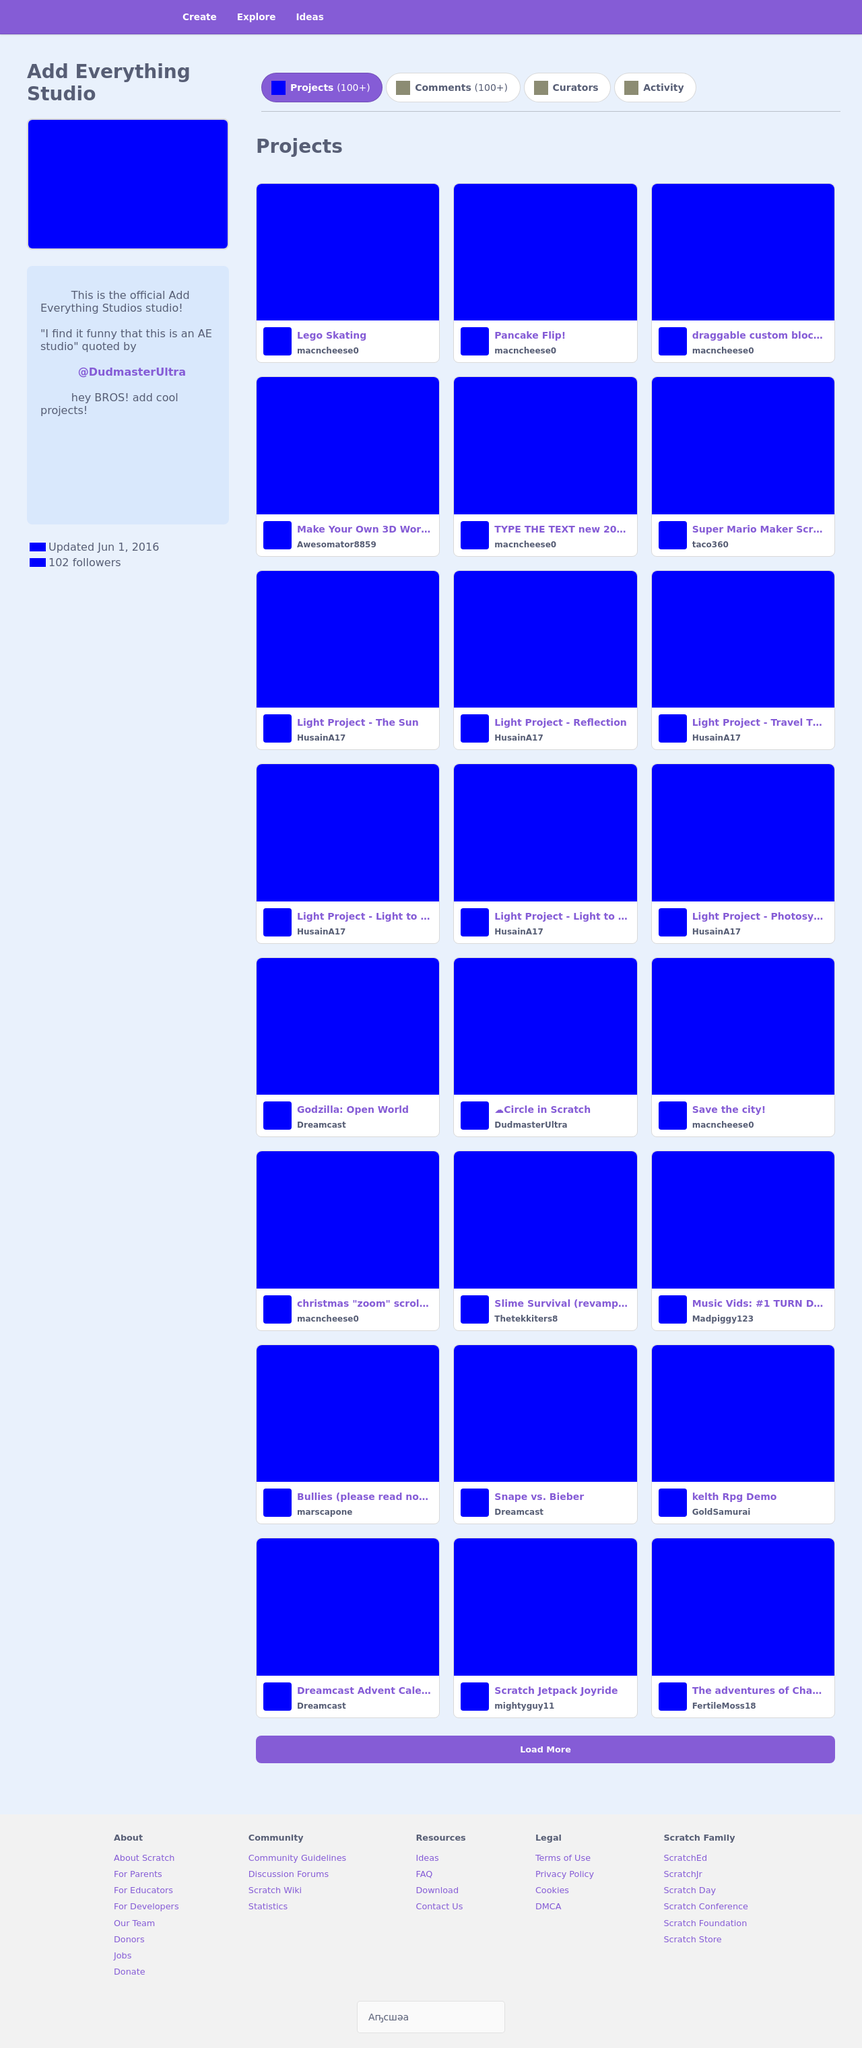What kind of interactions can users have on this website? Users on this website can engage in various interactions such as browsing through a collection of projects, clicking on projects to get more information, and possibly commenting on projects if enabled. There appear to be tabs for projects, comments, curators, and activity, suggesting a community-oriented platform where users can also manage projects and collaborate with others. 